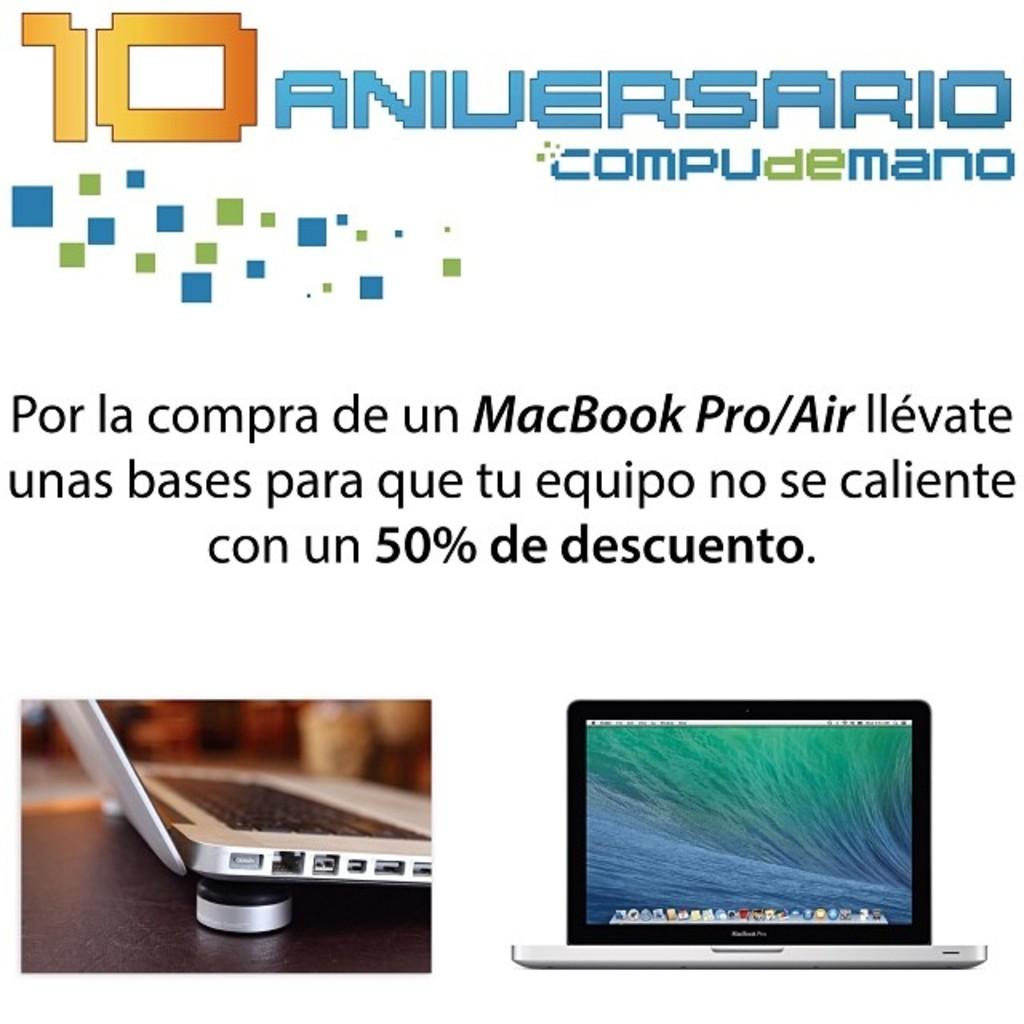What percent discount can you get?
Your answer should be very brief. 50. What are they selling?
Provide a short and direct response. Macbook pro/air. 